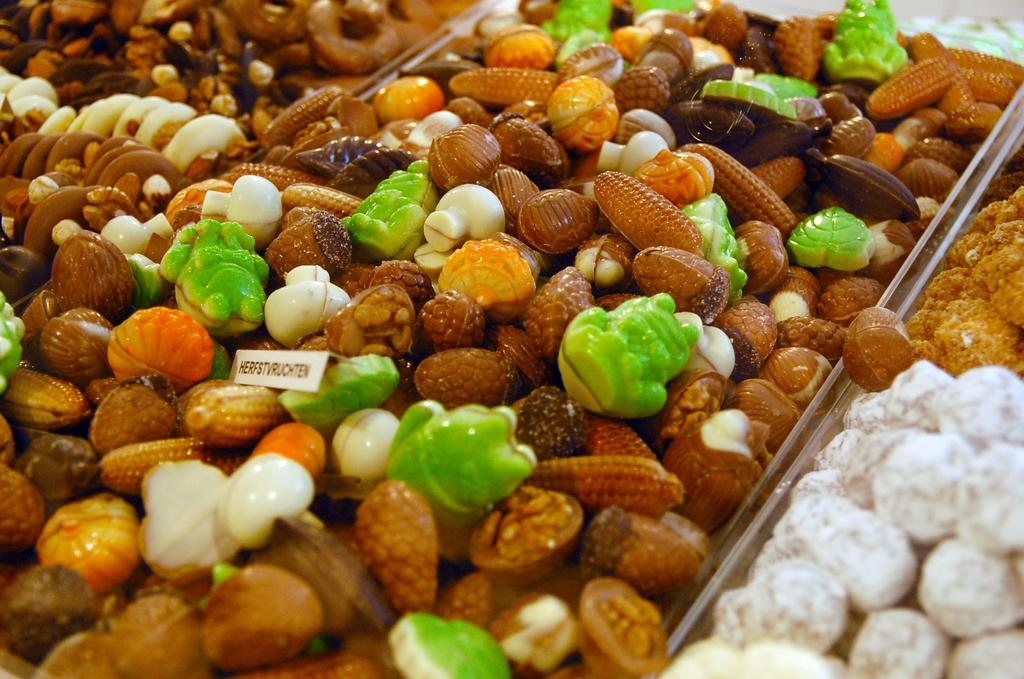What kind of objects are in the image? There are different types of plastic toys in the image. Where are the toys located? The toys are in a box. Can you describe the setting where the image might have been taken? The image may have been taken in a market. What type of branch can be seen growing out of the mouth of one of the toys in the image? There is no branch or mouth present on any of the toys in the image. 